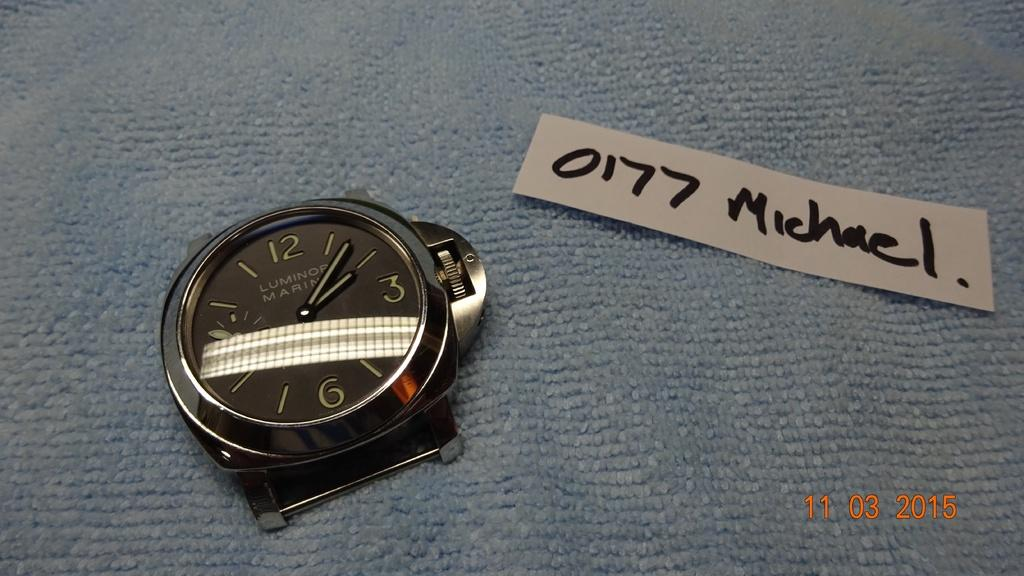<image>
Write a terse but informative summary of the picture. A WATCH WITH NO BAND AND A WHITE TAG SAYING 0177 MICHAEL 